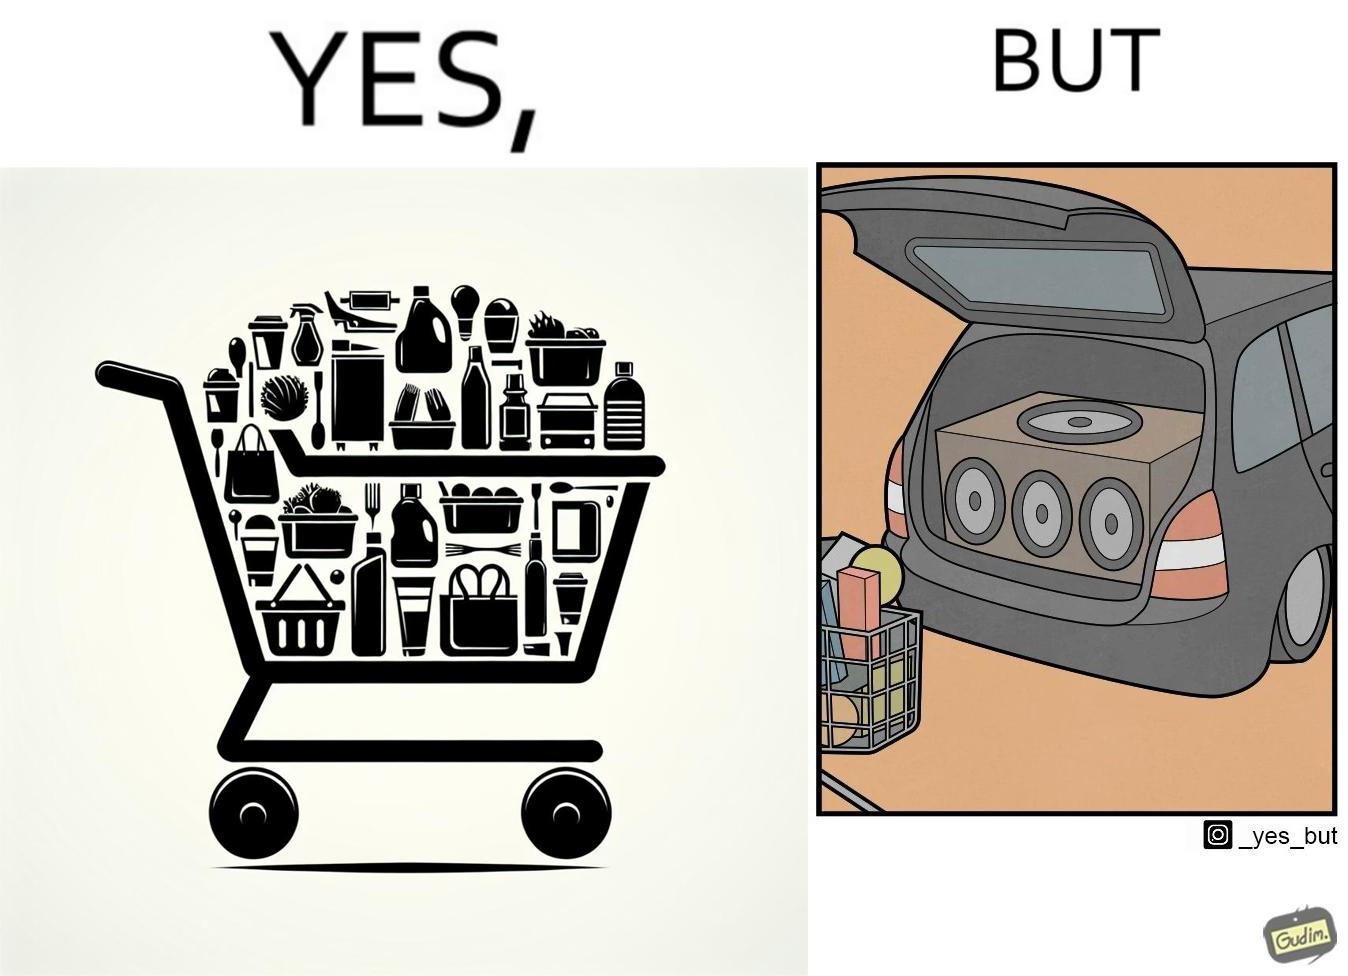Does this image contain satire or humor? Yes, this image is satirical. 